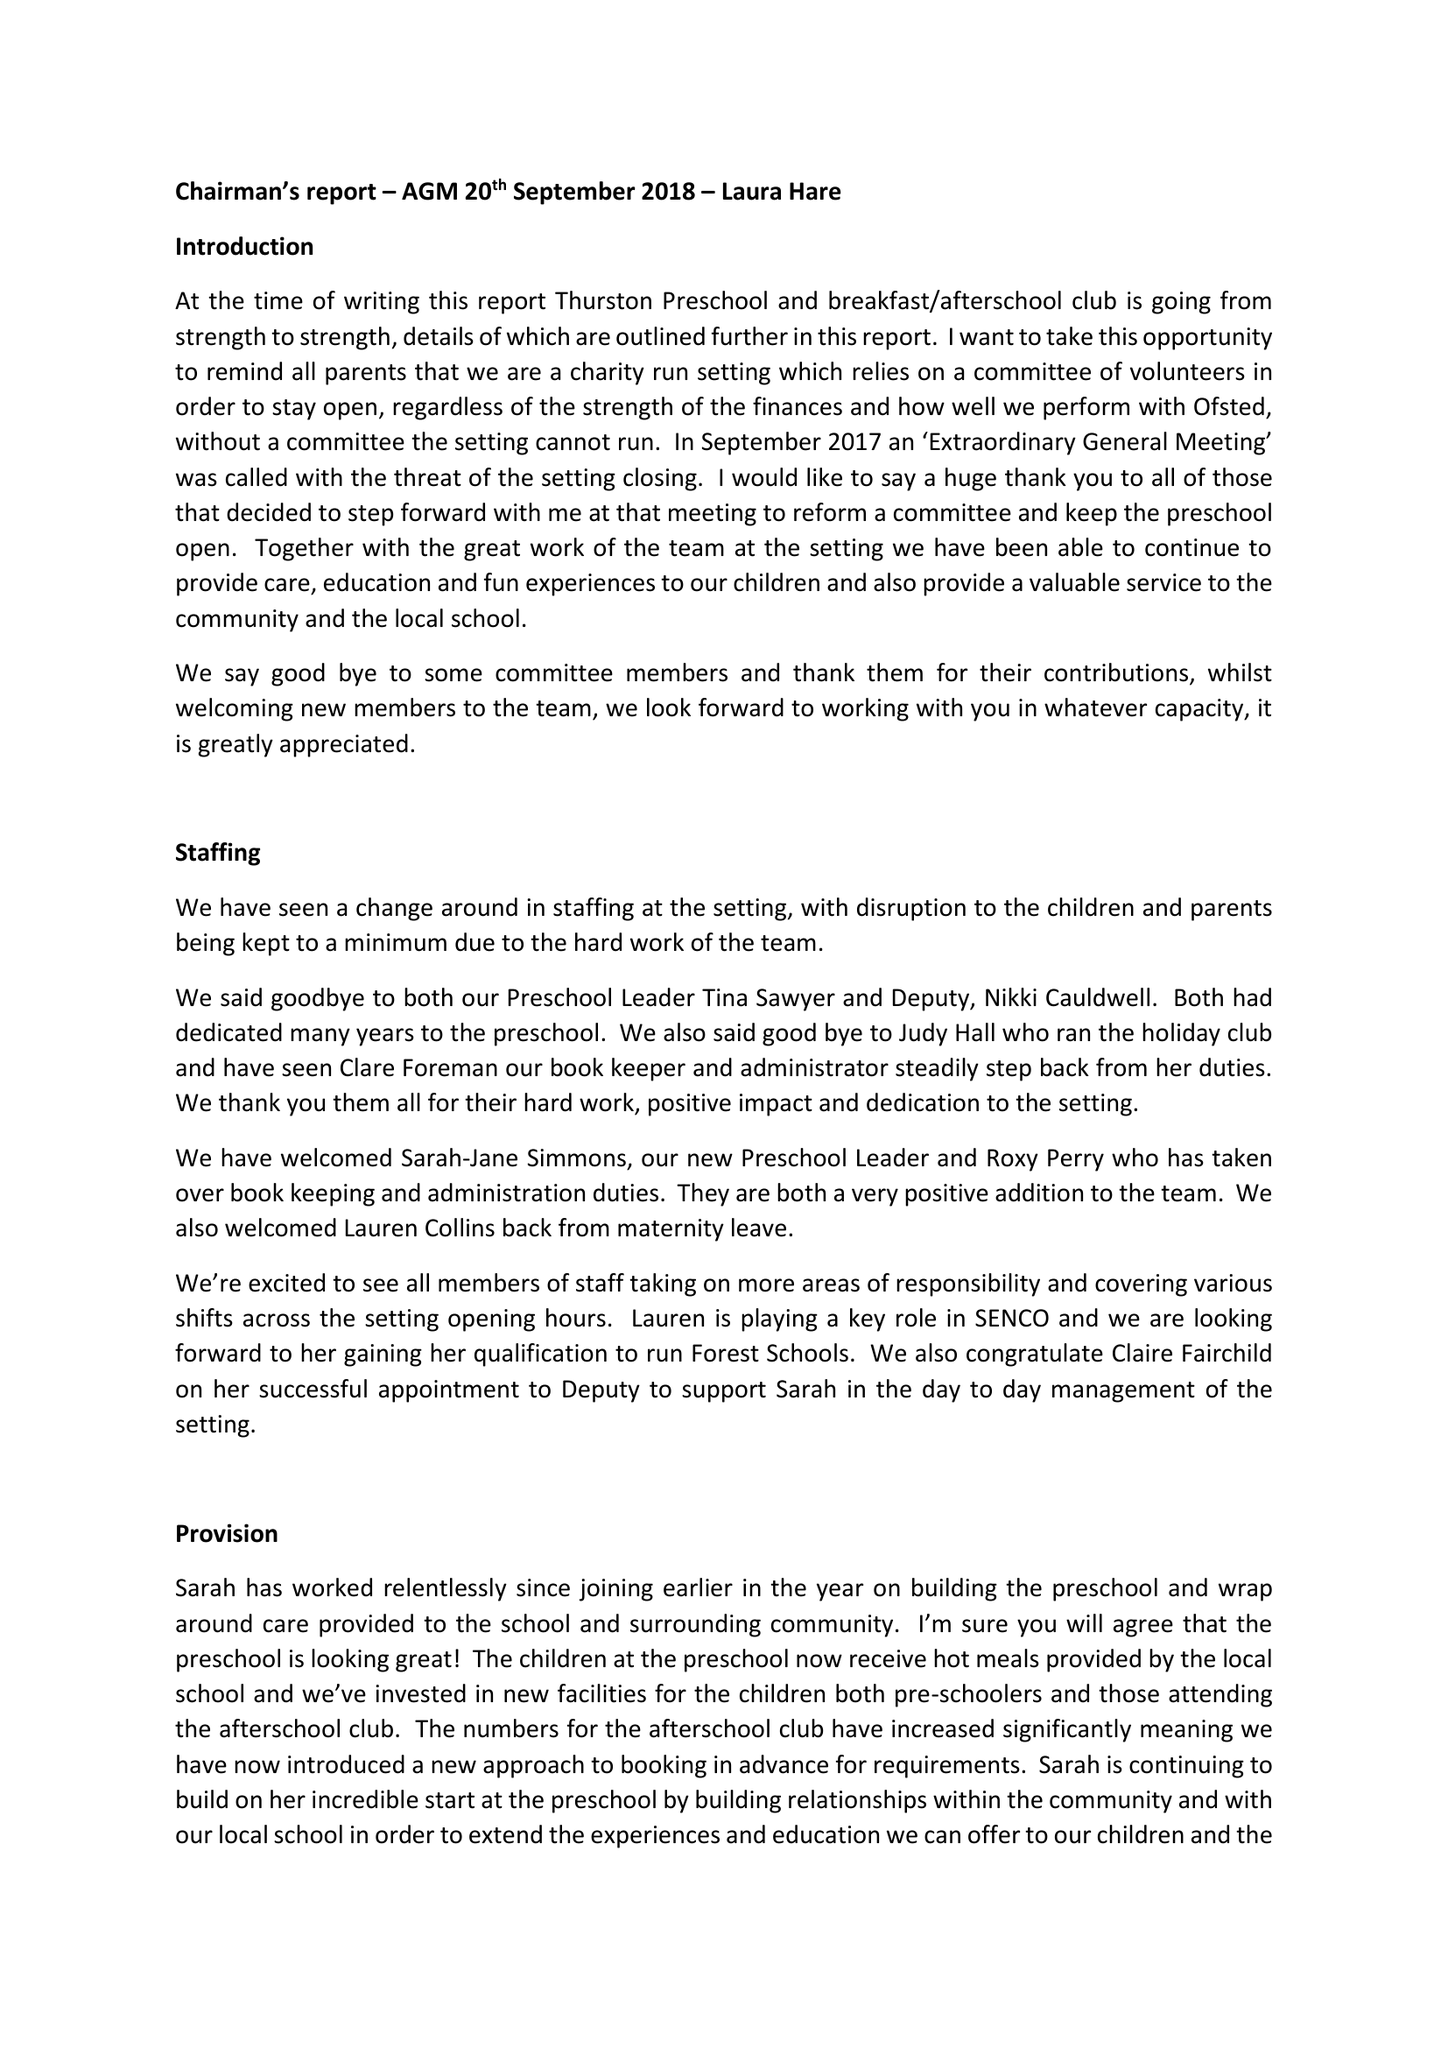What is the value for the charity_number?
Answer the question using a single word or phrase. 1144602 